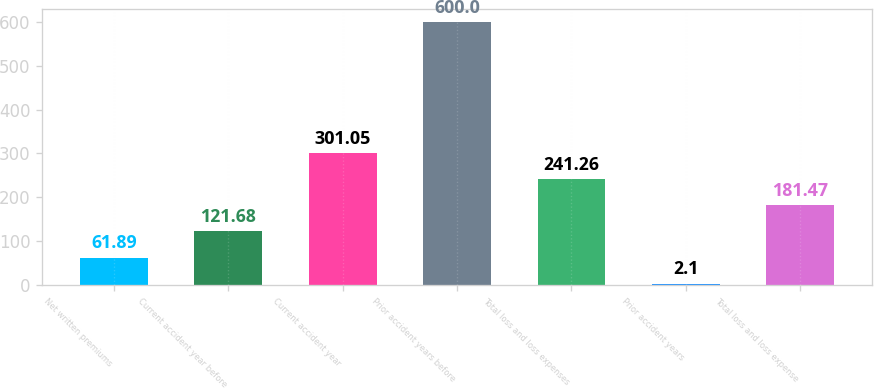Convert chart. <chart><loc_0><loc_0><loc_500><loc_500><bar_chart><fcel>Net written premiums<fcel>Current accident year before<fcel>Current accident year<fcel>Prior accident years before<fcel>Total loss and loss expenses<fcel>Prior accident years<fcel>Total loss and loss expense<nl><fcel>61.89<fcel>121.68<fcel>301.05<fcel>600<fcel>241.26<fcel>2.1<fcel>181.47<nl></chart> 